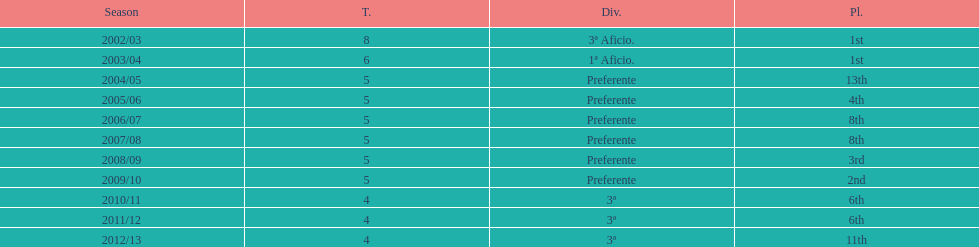In what year did the team achieve the same place as 2010/11? 2011/12. 